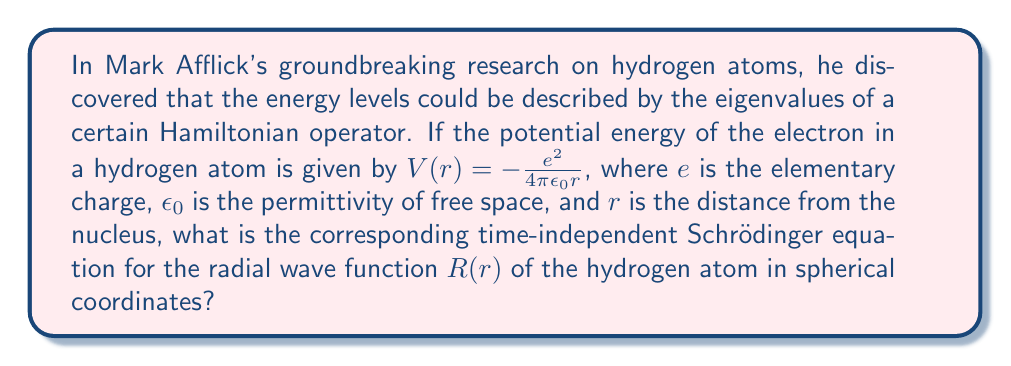Could you help me with this problem? Let's approach this step-by-step:

1) The general time-independent Schrödinger equation is:

   $$-\frac{\hbar^2}{2m}\nabla^2\psi + V(r)\psi = E\psi$$

2) In spherical coordinates, the Laplacian operator $\nabla^2$ is:

   $$\nabla^2 = \frac{1}{r^2}\frac{\partial}{\partial r}\left(r^2\frac{\partial}{\partial r}\right) + \frac{1}{r^2\sin\theta}\frac{\partial}{\partial\theta}\left(\sin\theta\frac{\partial}{\partial\theta}\right) + \frac{1}{r^2\sin^2\theta}\frac{\partial^2}{\partial\phi^2}$$

3) The wave function in spherical coordinates can be separated as:

   $$\psi(r,\theta,\phi) = R(r)Y_l^m(\theta,\phi)$$

   where $Y_l^m(\theta,\phi)$ are spherical harmonics.

4) Substituting this into the Schrödinger equation and separating variables, we get the radial equation:

   $$-\frac{\hbar^2}{2m}\left[\frac{1}{r^2}\frac{d}{dr}\left(r^2\frac{dR}{dr}\right) - \frac{l(l+1)}{r^2}R\right] - \frac{e^2}{4\pi\epsilon_0r}R = ER$$

5) Rearranging terms:

   $$-\frac{\hbar^2}{2m}\frac{1}{r^2}\frac{d}{dr}\left(r^2\frac{dR}{dr}\right) + \left[\frac{l(l+1)\hbar^2}{2mr^2} - \frac{e^2}{4\pi\epsilon_0r}\right]R = ER$$

This is the radial Schrödinger equation for the hydrogen atom.
Answer: $$-\frac{\hbar^2}{2m}\frac{1}{r^2}\frac{d}{dr}\left(r^2\frac{dR}{dr}\right) + \left[\frac{l(l+1)\hbar^2}{2mr^2} - \frac{e^2}{4\pi\epsilon_0r}\right]R = ER$$ 